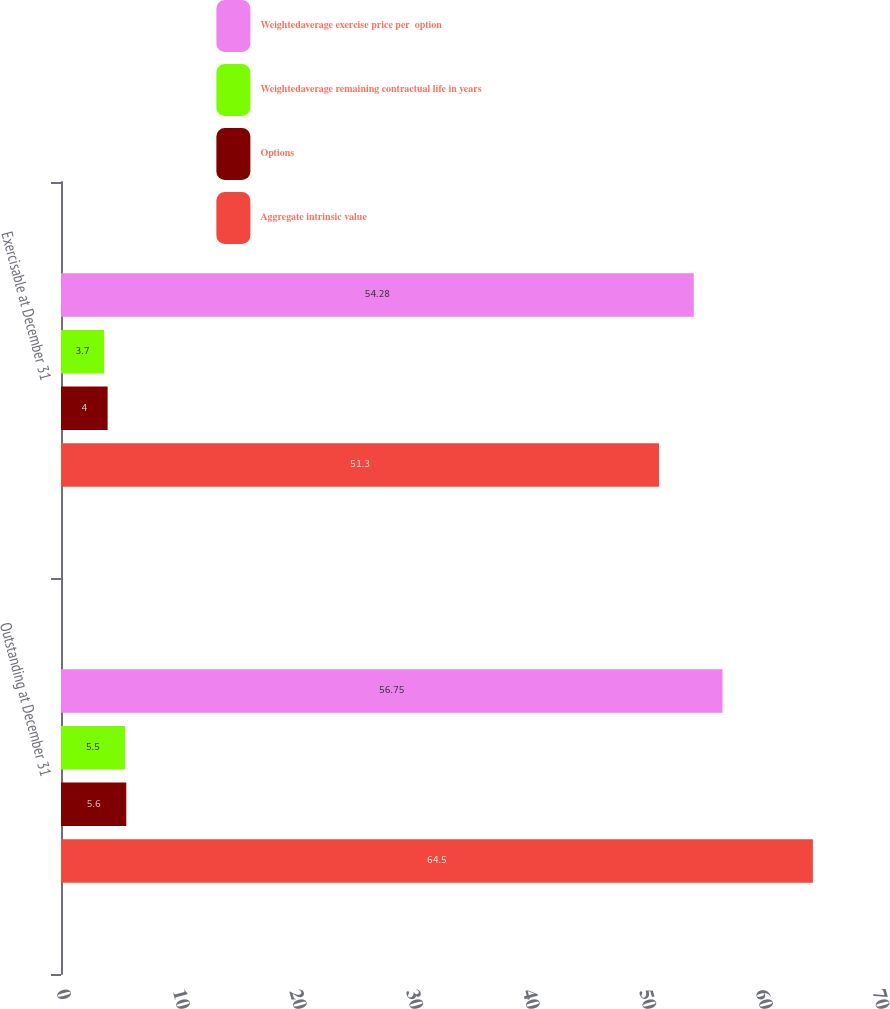Convert chart to OTSL. <chart><loc_0><loc_0><loc_500><loc_500><stacked_bar_chart><ecel><fcel>Outstanding at December 31<fcel>Exercisable at December 31<nl><fcel>Weightedaverage exercise price per  option<fcel>56.75<fcel>54.28<nl><fcel>Weightedaverage remaining contractual life in years<fcel>5.5<fcel>3.7<nl><fcel>Options<fcel>5.6<fcel>4<nl><fcel>Aggregate intrinsic value<fcel>64.5<fcel>51.3<nl></chart> 